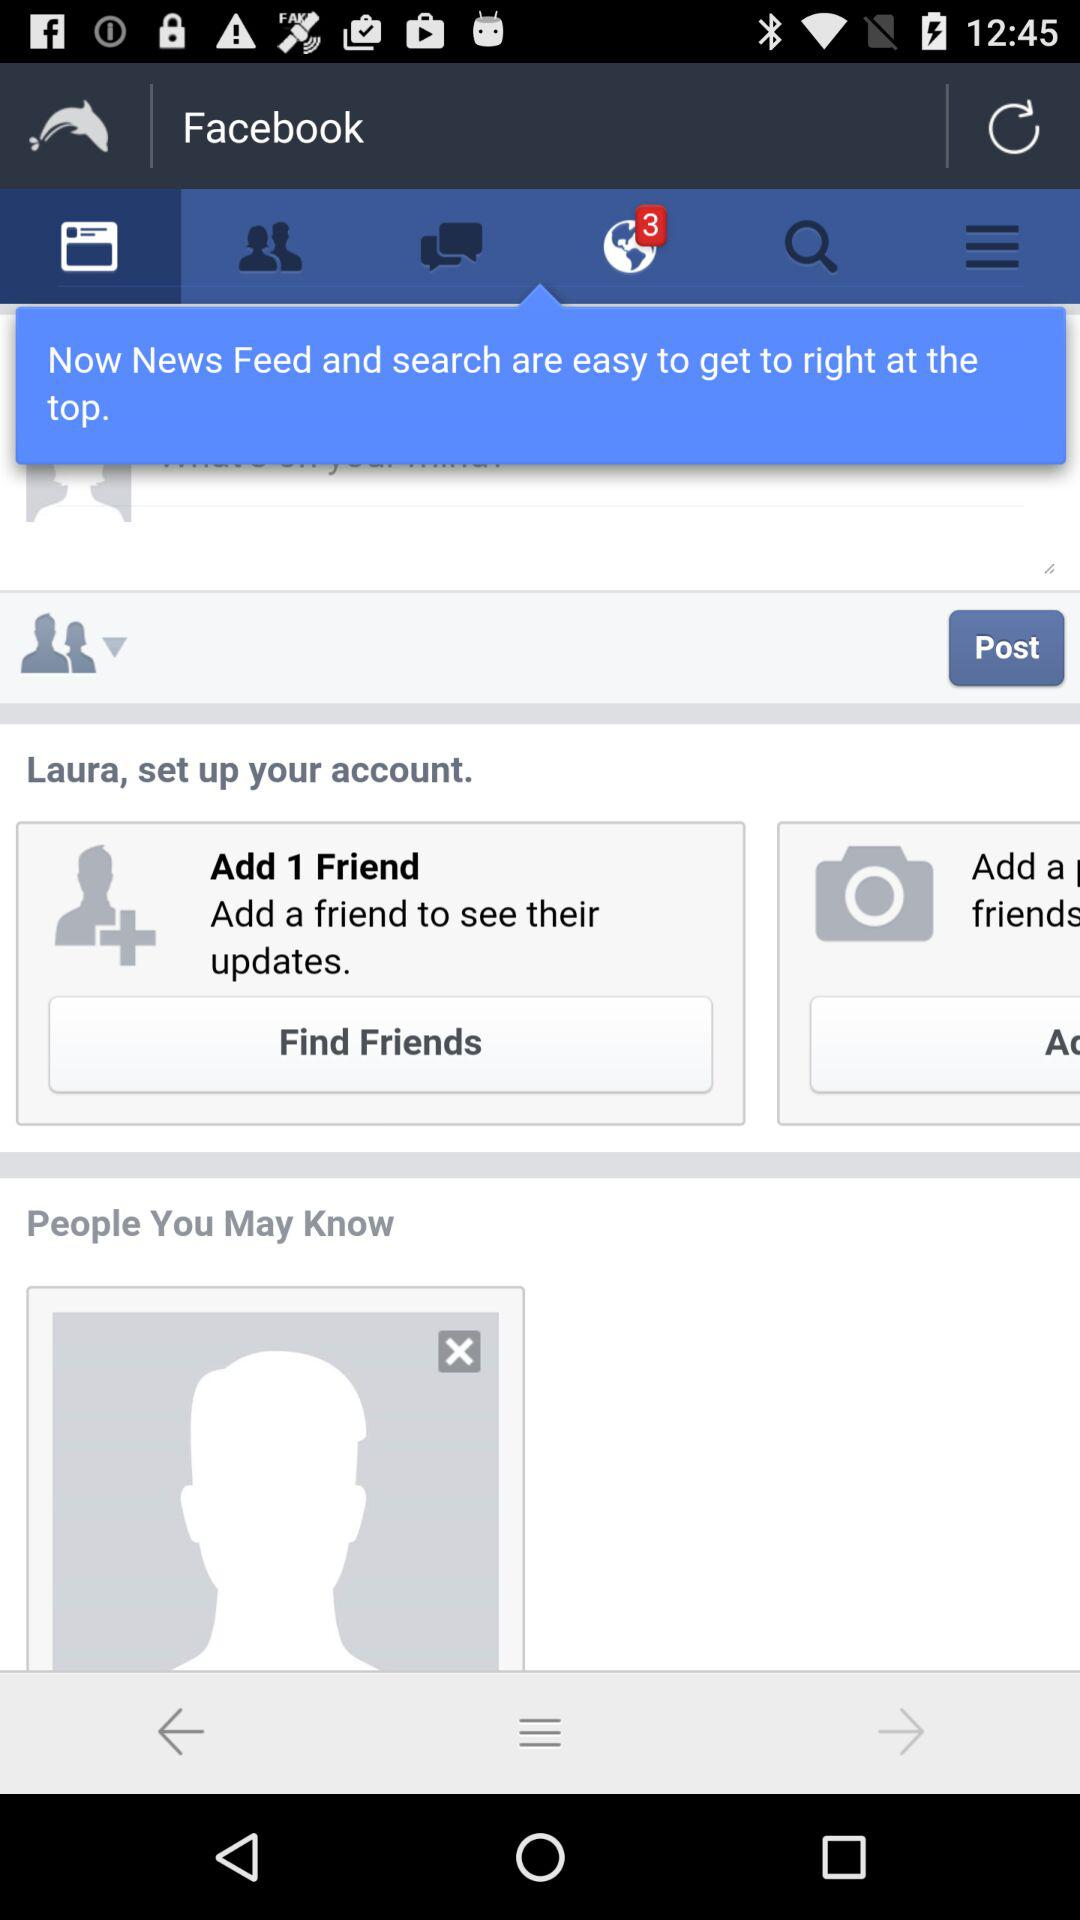What is the application name? The application name is "Facebook". 